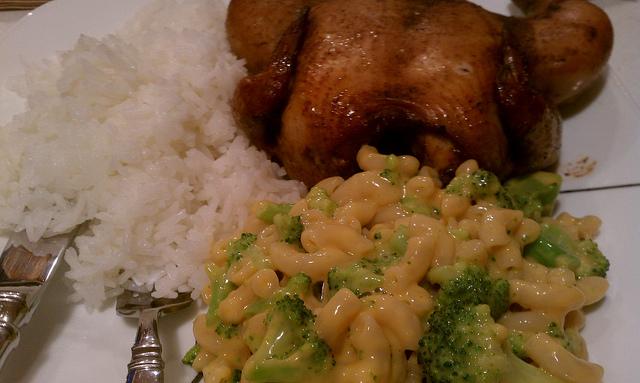What kind of meat is this?
Short answer required. Chicken. What is mixed with the macaroni and cheese?
Answer briefly. Broccoli. What foods here are high in carbohydrates?
Answer briefly. Rice. What is the name of the basil sauce on the pasta?
Answer briefly. Cheese. What type of cheese is that?
Be succinct. Cheddar. Is chicken on the plate?
Keep it brief. Yes. Does this person have fries with their meal?
Answer briefly. No. Is this a vegetarian meal?
Give a very brief answer. No. What color is the garnish to the right of the food?
Be succinct. Green. What is the meat on the left?
Quick response, please. Chicken. Is this meal vegetarian?
Short answer required. No. Where is the fork?
Be succinct. Under rice. What is that cut of meat?
Write a very short answer. Chicken. What is this vegetable called?
Answer briefly. Broccoli. 